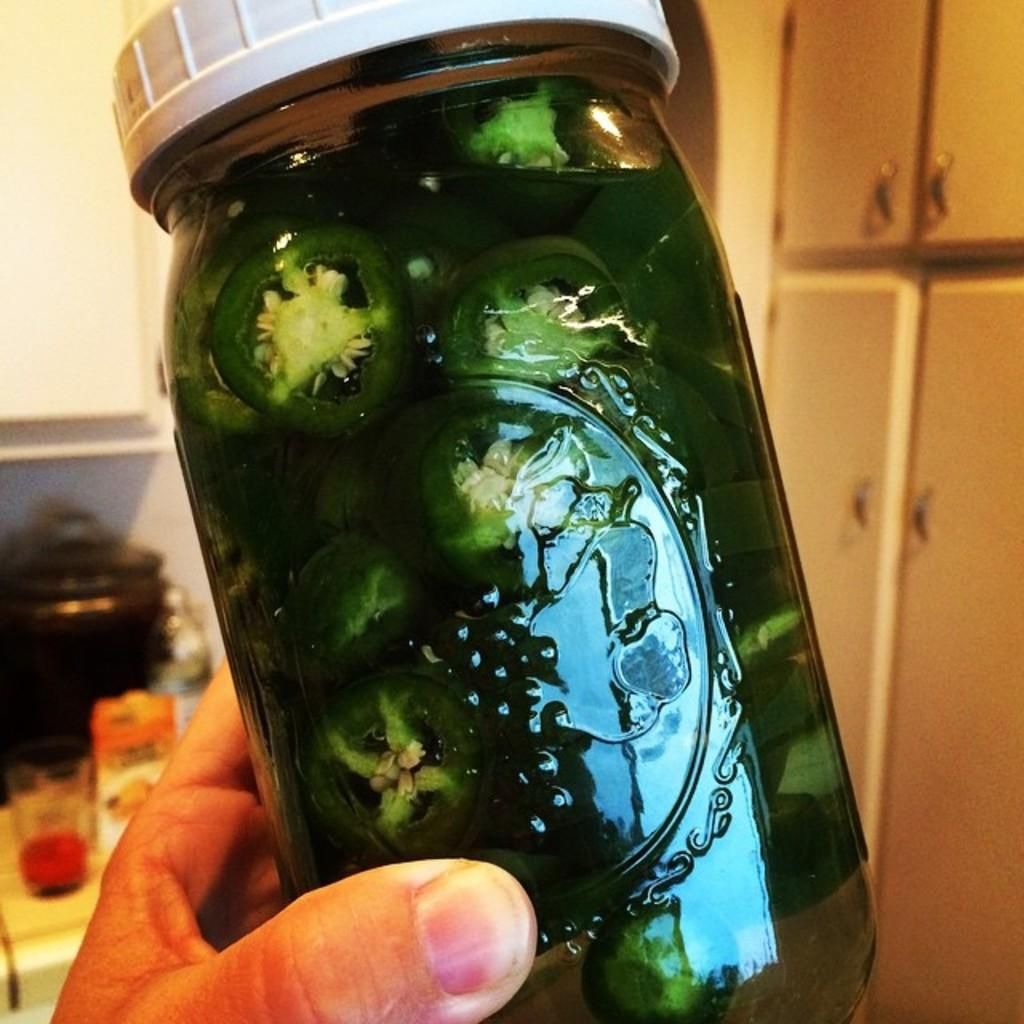What type of container is visible in the image? There is a glass bottle in the image. What color is the glass bottle? The glass bottle is green in color. Does the glass bottle have a cap? Yes, the glass bottle has a cap. What part of a person can be seen in the image? A human finger is present in the image. What type of branch is visible in the image? There is no branch present in the image. Is the glass bottle sitting on a desk in the image? The provided facts do not mention a desk, so we cannot determine if the glass bottle is sitting on one. 